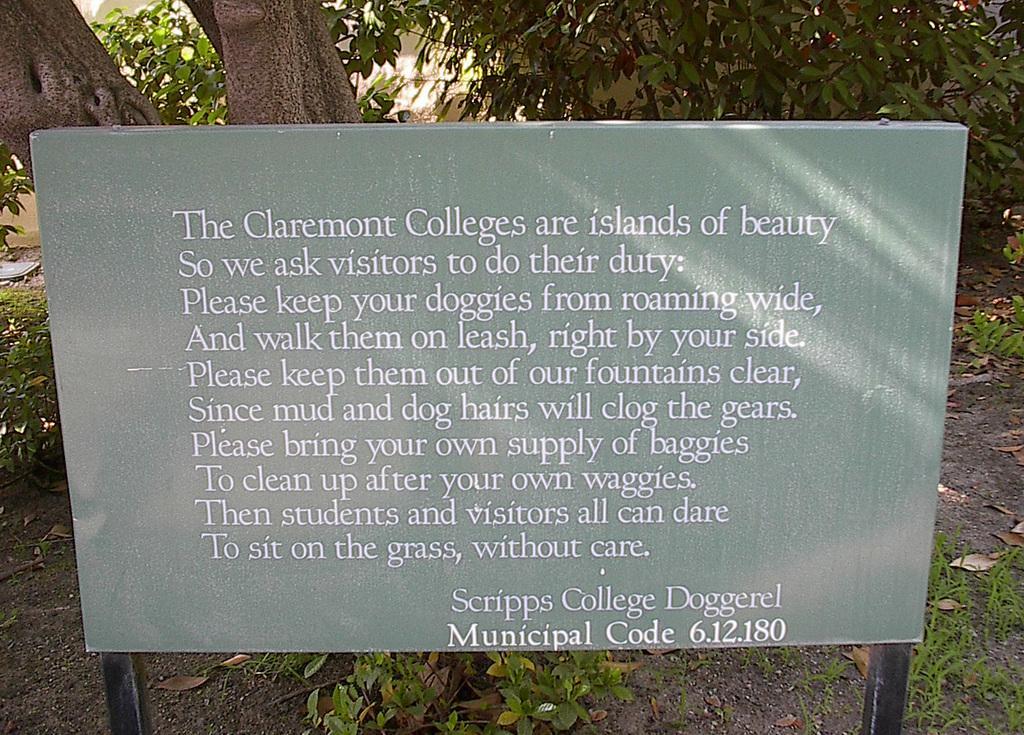Can you describe this image briefly? In this image we can see a board on which some text is written and in the background of the image there are some trees and houses. 